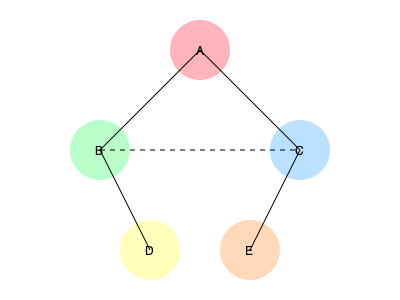In this research collaboration network diagram, which researcher acts as the primary bridge between two distinct subgroups, and how many direct collaborations does this researcher have? To answer this question, we need to analyze the network diagram step-by-step:

1. Identify the nodes: There are 5 nodes (A, B, C, D, E) representing researchers.

2. Analyze the connections:
   - A is connected to B and C
   - B is connected to A and D
   - C is connected to A and E
   - D is connected to B
   - E is connected to C
   - B and C have a dashed line between them, indicating an indirect connection

3. Identify subgroups:
   - Subgroup 1: A, B, D
   - Subgroup 2: A, C, E

4. Identify the bridge:
   - Researcher A is the only node connected to both subgroups directly
   - A is the primary bridge between the two subgroups

5. Count A's direct collaborations:
   - A is directly connected to B and C
   - Therefore, A has 2 direct collaborations

Thus, researcher A acts as the primary bridge between the two subgroups and has 2 direct collaborations.
Answer: Researcher A; 2 collaborations 